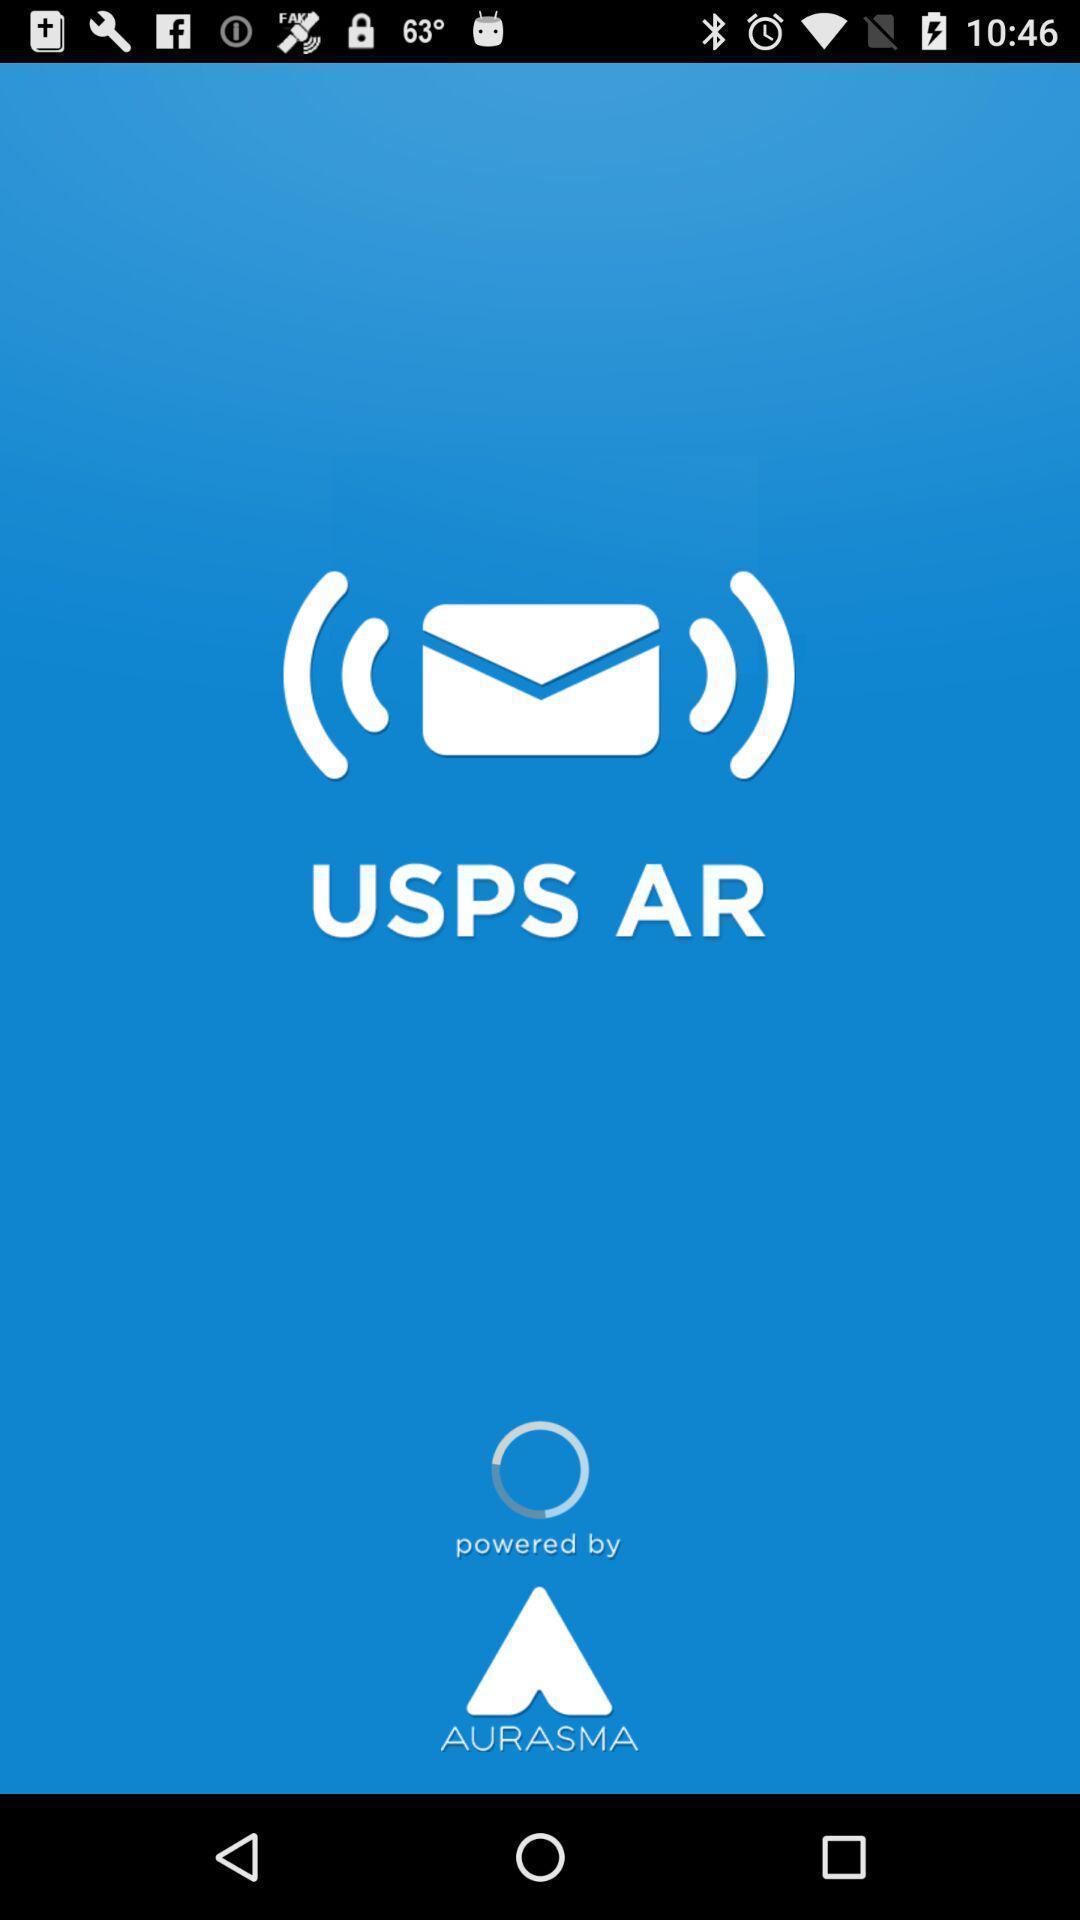Give me a narrative description of this picture. Welcome page of a messaging application. 